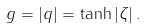<formula> <loc_0><loc_0><loc_500><loc_500>g = | q | = \tanh | \zeta | \, .</formula> 